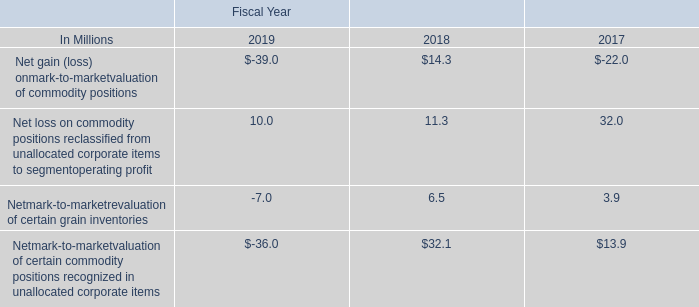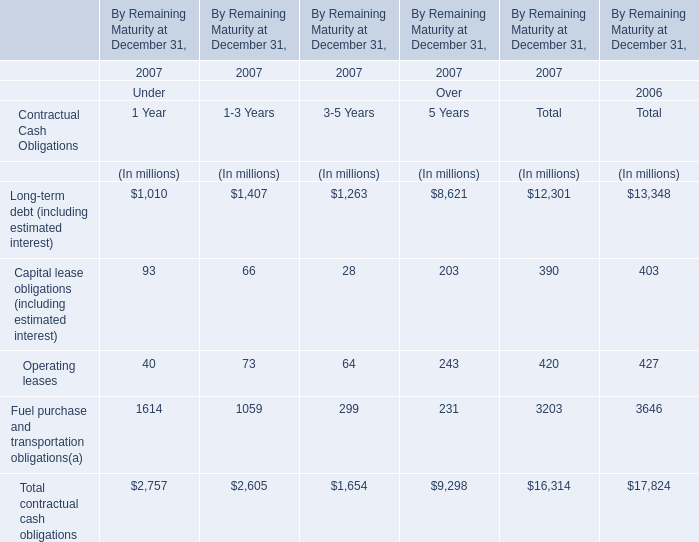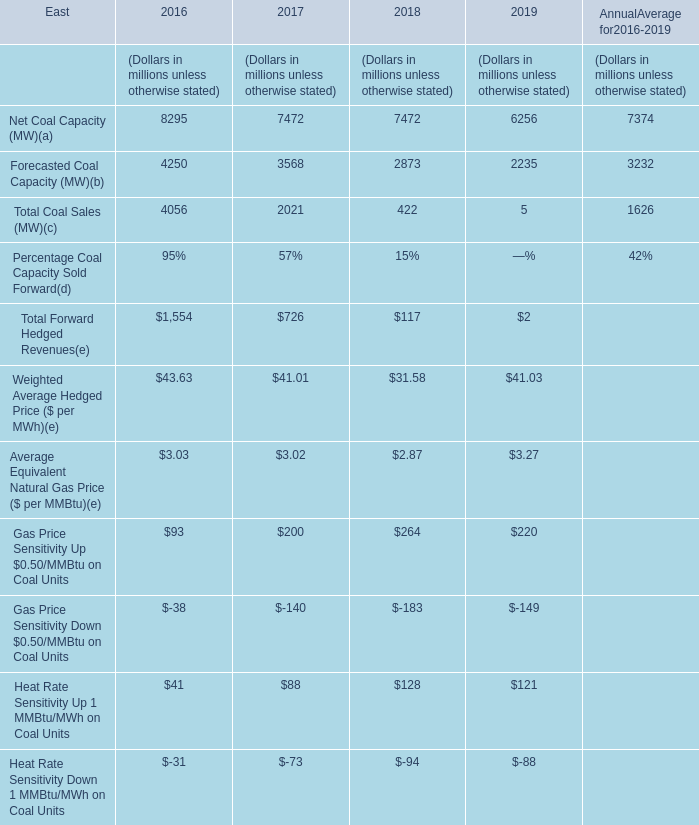What was the total amount of Net Coal Capacity (MW)( and Forecasted Coal Capacity in 2016? (in million) 
Computations: (8295 + 4250)
Answer: 12545.0. 